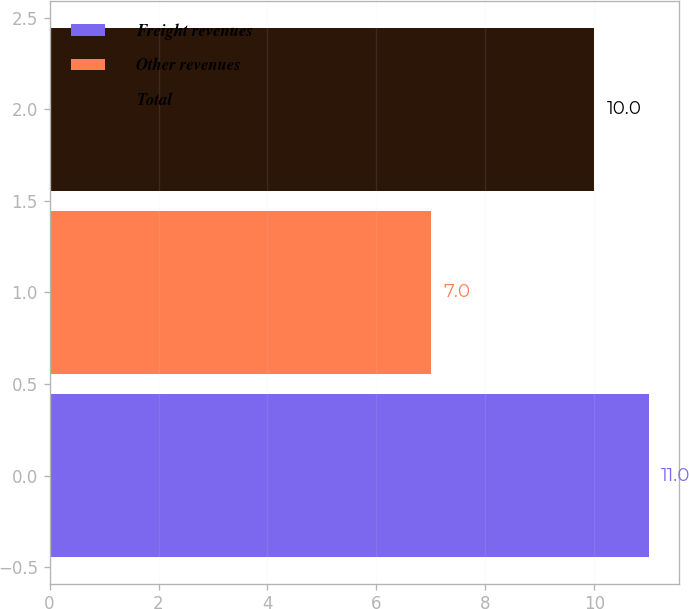<chart> <loc_0><loc_0><loc_500><loc_500><bar_chart><fcel>Freight revenues<fcel>Other revenues<fcel>Total<nl><fcel>11<fcel>7<fcel>10<nl></chart> 